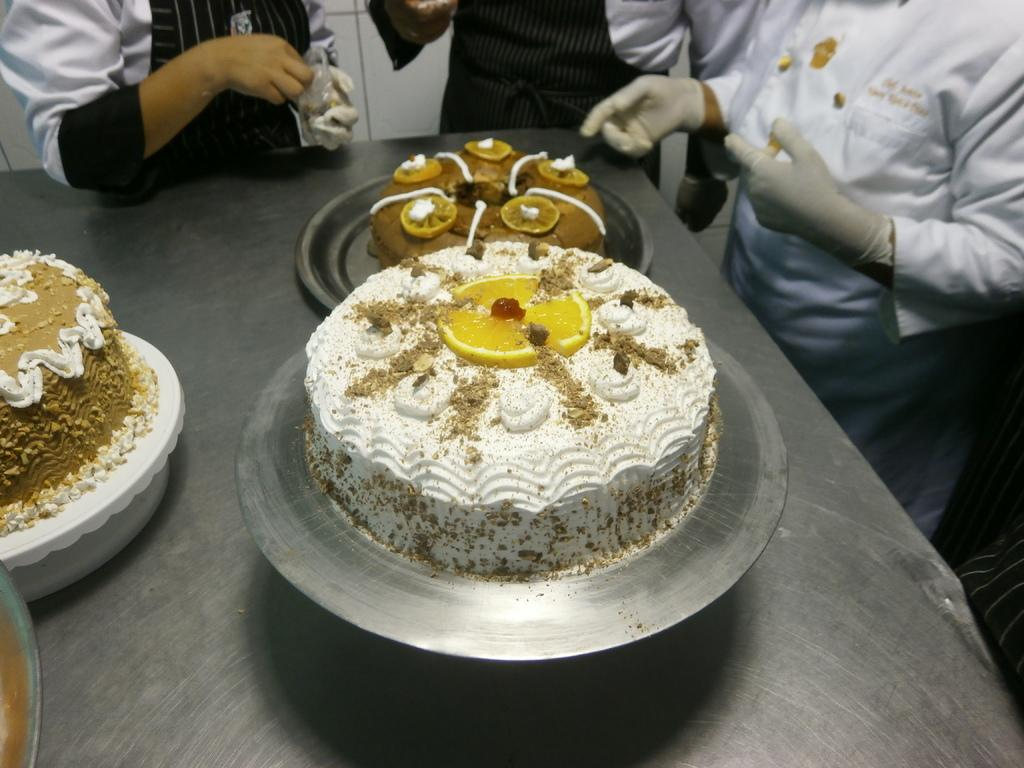What is on the plate in the image? There is a plate with food in the image. Can you describe the color of the food? The food is in brown color. What is the color of the surface the plate is on? The plate is on a silver color surface. How many people are in the image? There are three people in the image. What colors are the dresses of the people in the image? The dresses of the people in the image are in white and black color. What type of representative is present in the image? There is no representative present in the image; it features a plate with food, a silver surface, and three people with white and black color dresses. Can you see any rays in the image? There are no rays visible in the image. 